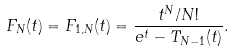<formula> <loc_0><loc_0><loc_500><loc_500>F _ { N } ( t ) = F _ { 1 , N } ( t ) = \frac { t ^ { N } / N ! } { e ^ { t } - T _ { N - 1 } ( t ) } .</formula> 